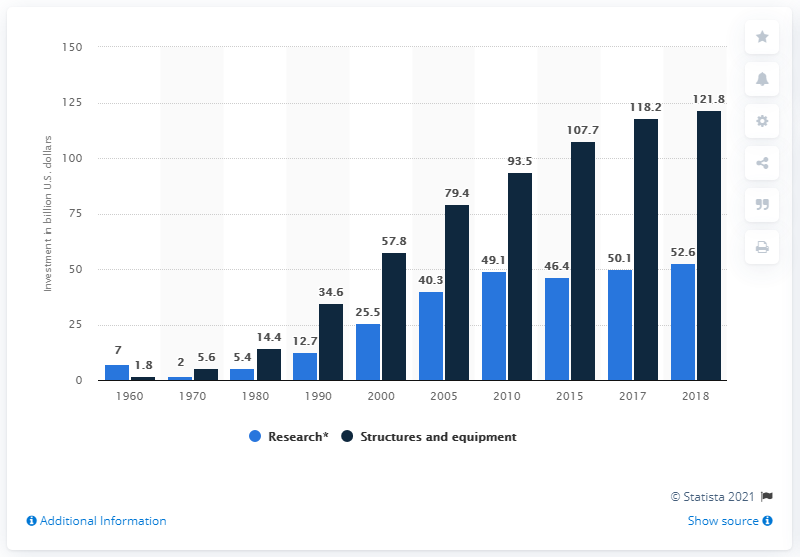Outline some significant characteristics in this image. In 2000, a total of $57.8 million was invested in structures and equipment. In 2000, a substantial amount of money was invested in research. 